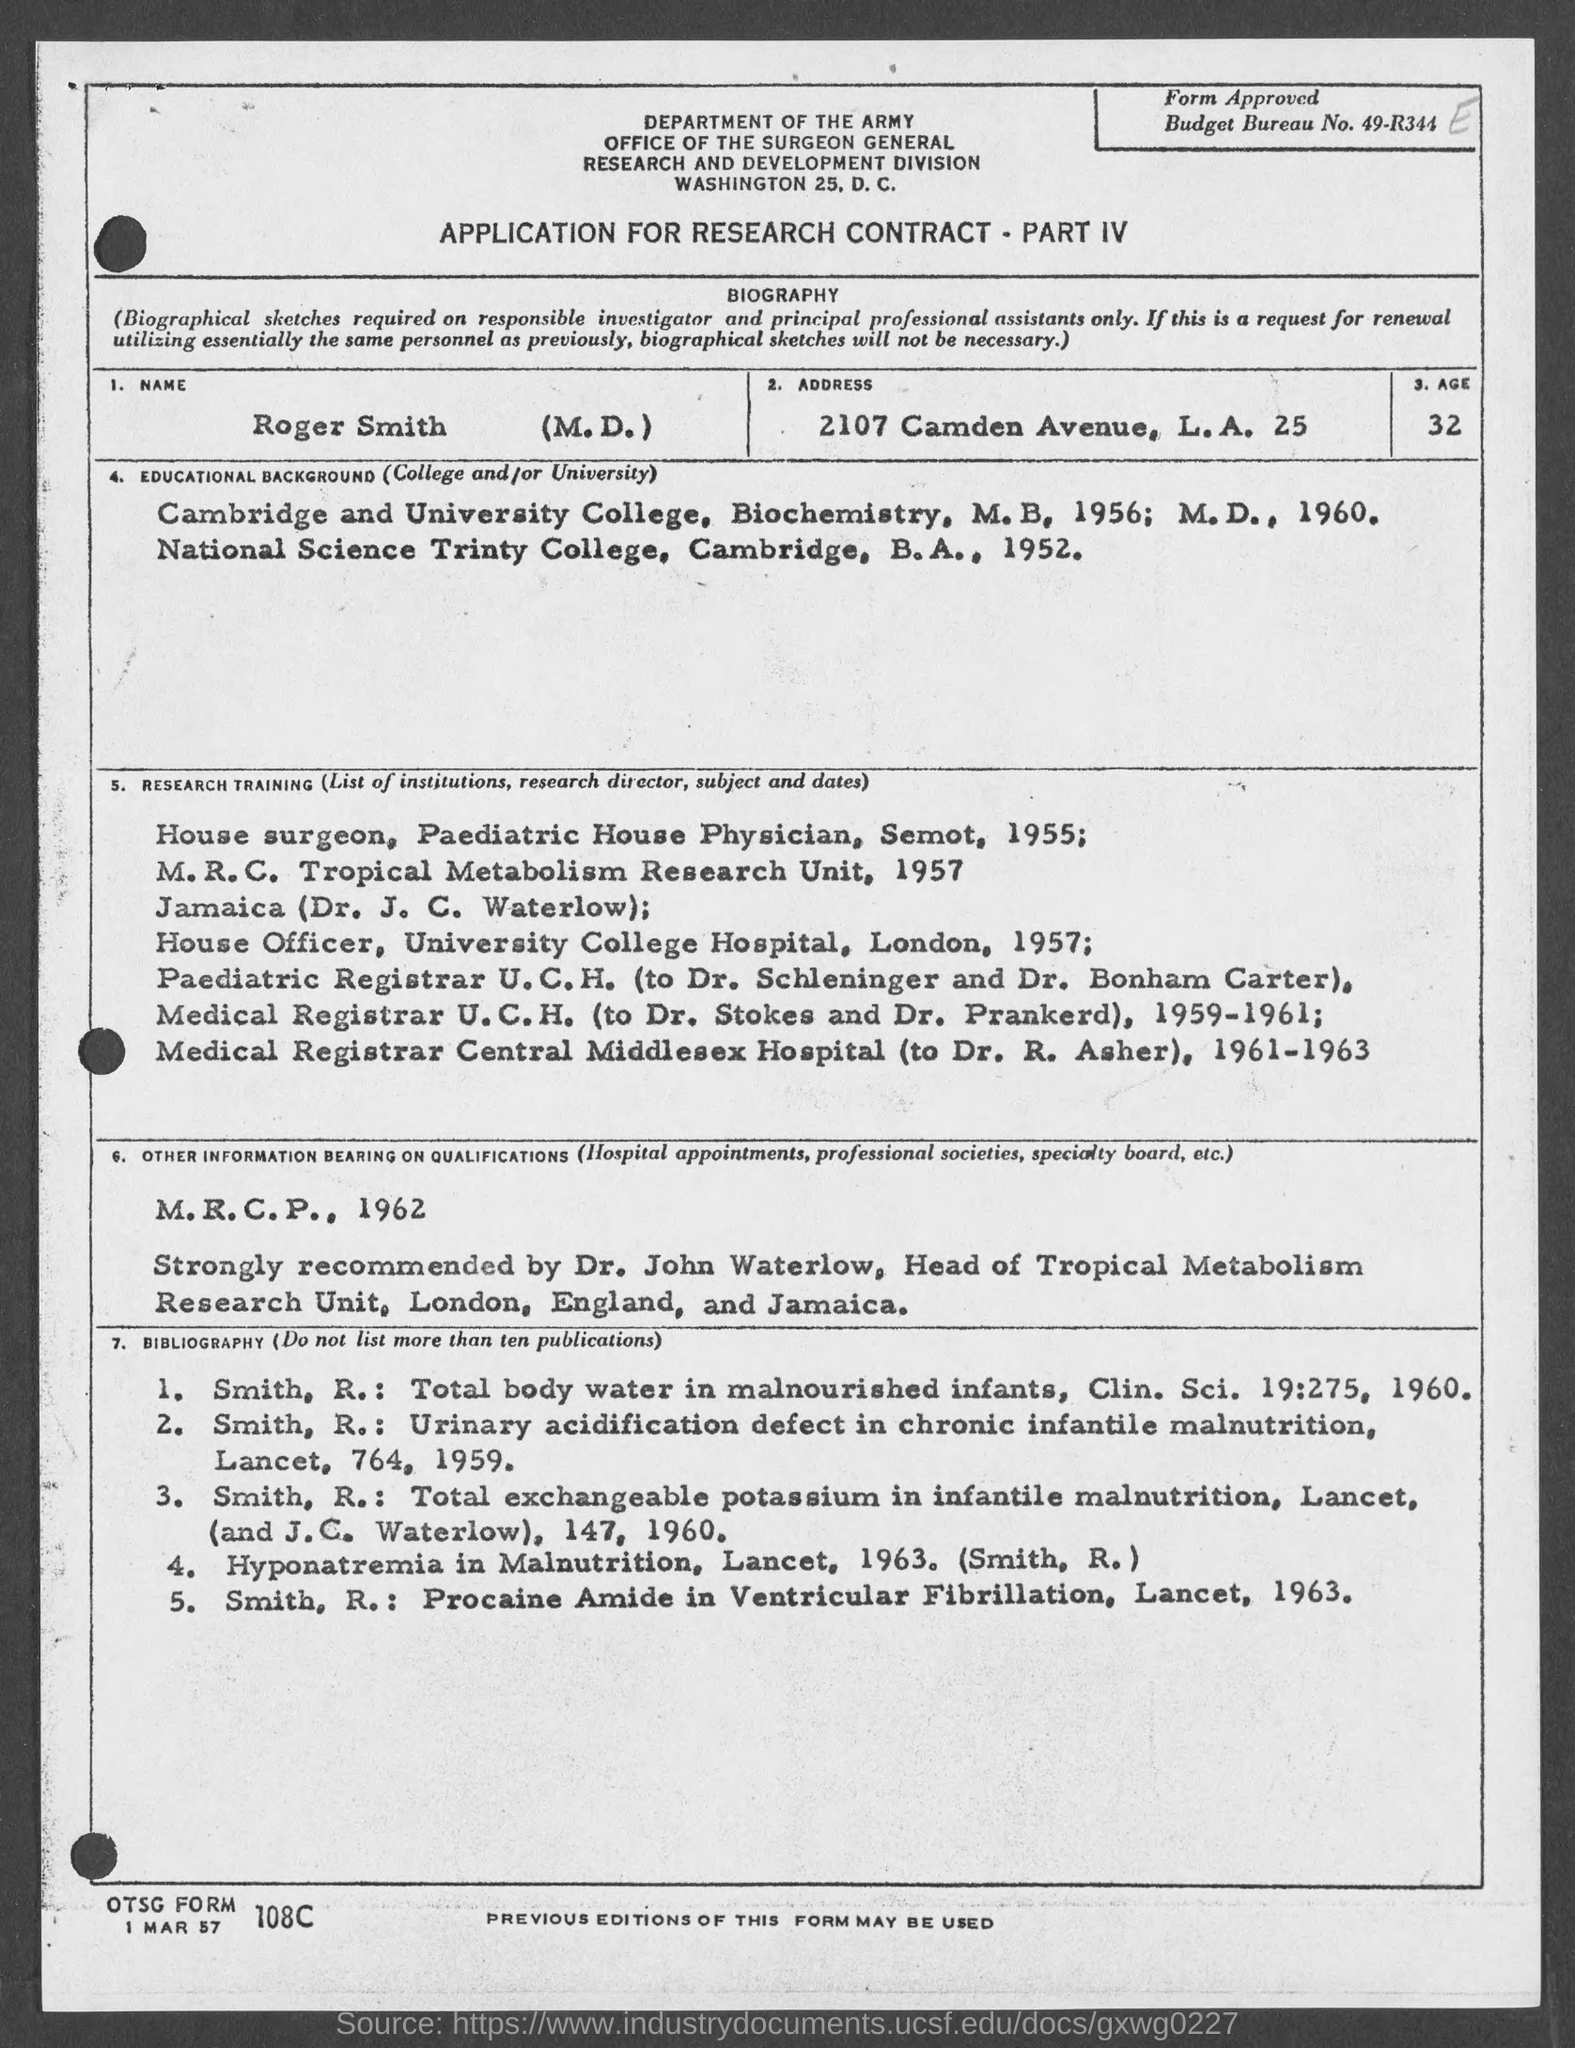Mention a couple of crucial points in this snapshot. The address provided in the application is 2107 Camden Avenue, Los Angeles 25.. Roger Smith (M.D.) served as a Medical Registrar at U.C.H. from 1959 to 1961, under the supervision of Dr. Stokes and Dr. Prankerd. In 1957, Roger Smith, who holds an M.D. degree, served as a House Officer at the University College Hospital in London. The name of the person specified in the application is Roger Smith (M.D.). The application form provides the Budget Bureau Number as 49-R344.. 